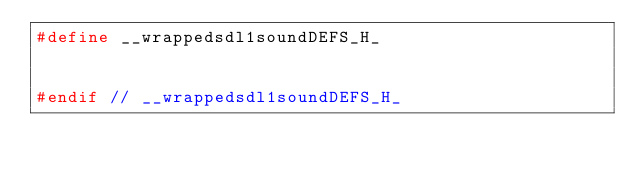<code> <loc_0><loc_0><loc_500><loc_500><_C_>#define __wrappedsdl1soundDEFS_H_


#endif // __wrappedsdl1soundDEFS_H_
</code> 